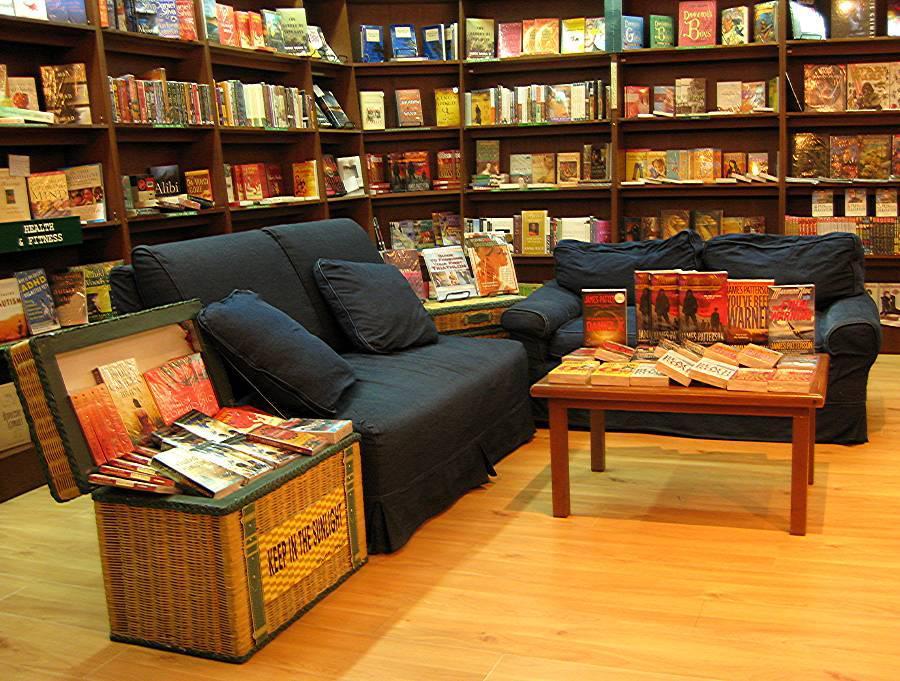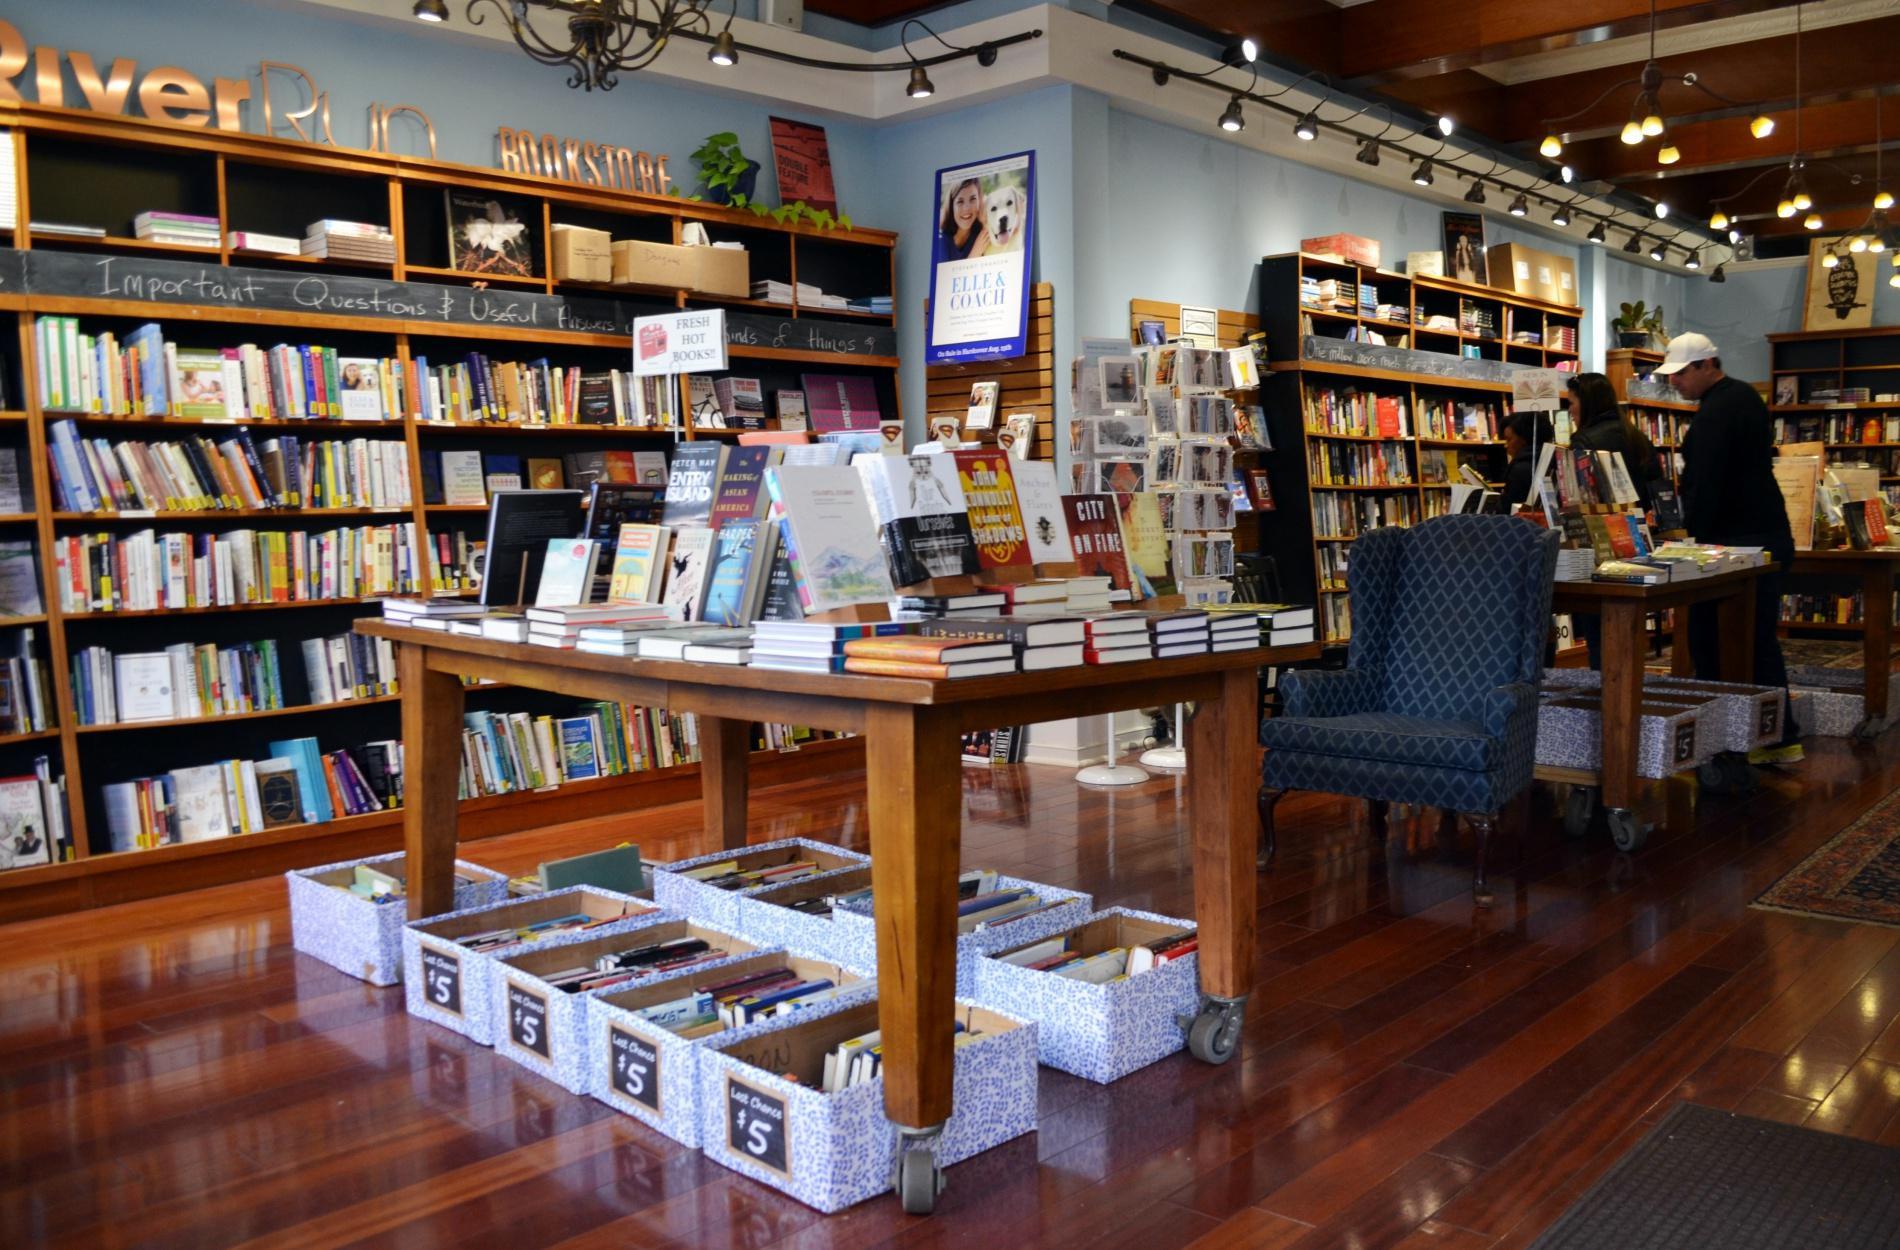The first image is the image on the left, the second image is the image on the right. Assess this claim about the two images: "At least one blue chair gives a seating area in the bookstore.". Correct or not? Answer yes or no. Yes. 